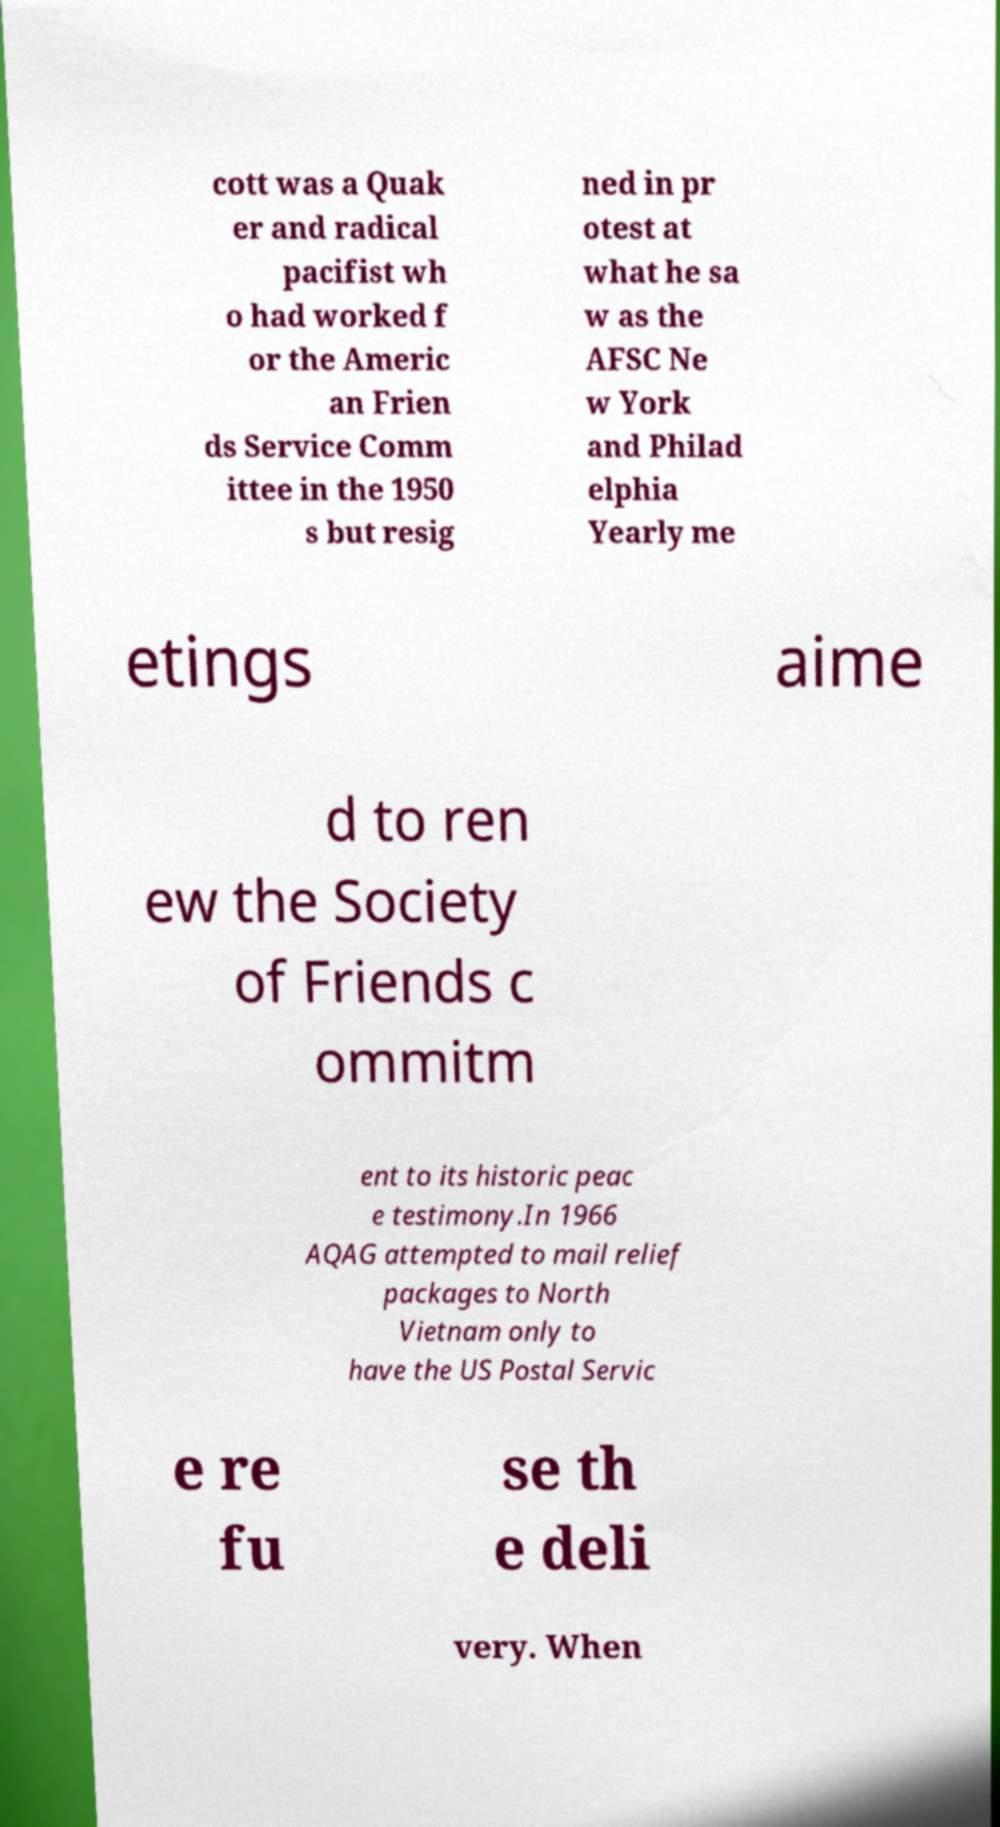Could you extract and type out the text from this image? cott was a Quak er and radical pacifist wh o had worked f or the Americ an Frien ds Service Comm ittee in the 1950 s but resig ned in pr otest at what he sa w as the AFSC Ne w York and Philad elphia Yearly me etings aime d to ren ew the Society of Friends c ommitm ent to its historic peac e testimony.In 1966 AQAG attempted to mail relief packages to North Vietnam only to have the US Postal Servic e re fu se th e deli very. When 